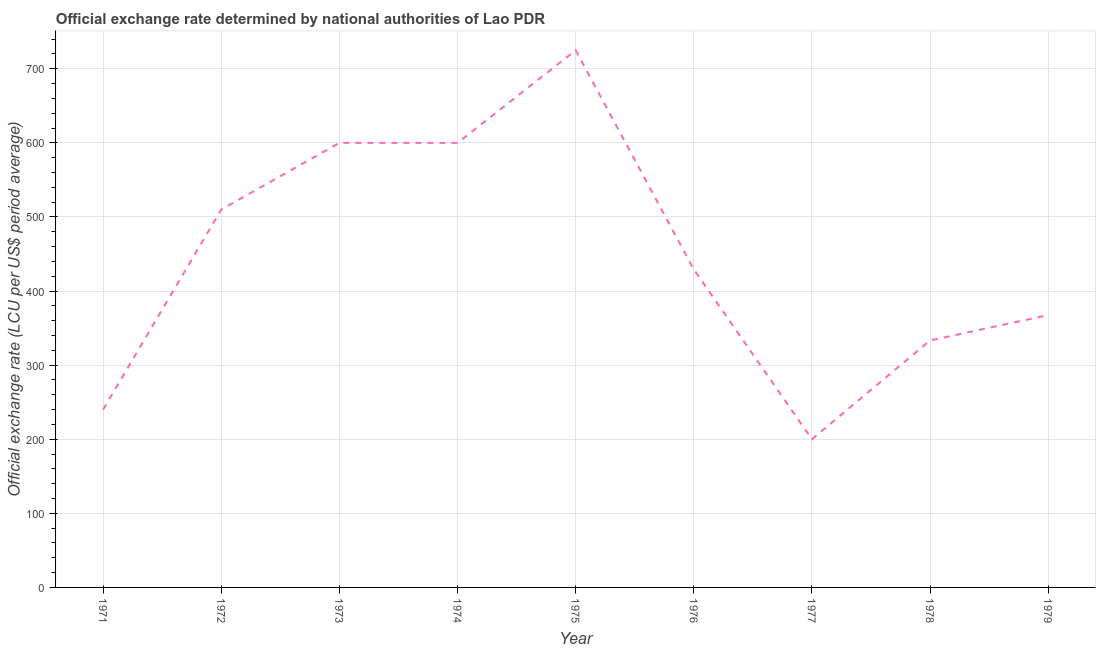What is the official exchange rate in 1978?
Offer a very short reply. 333.33. Across all years, what is the maximum official exchange rate?
Make the answer very short. 725. Across all years, what is the minimum official exchange rate?
Keep it short and to the point. 200. In which year was the official exchange rate maximum?
Offer a terse response. 1975. In which year was the official exchange rate minimum?
Your response must be concise. 1977. What is the sum of the official exchange rate?
Keep it short and to the point. 4005. What is the difference between the official exchange rate in 1975 and 1978?
Your answer should be very brief. 391.67. What is the average official exchange rate per year?
Ensure brevity in your answer.  445. What is the median official exchange rate?
Keep it short and to the point. 429.17. In how many years, is the official exchange rate greater than 360 ?
Your response must be concise. 6. Do a majority of the years between 1978 and 1976 (inclusive) have official exchange rate greater than 480 ?
Your answer should be very brief. No. What is the ratio of the official exchange rate in 1973 to that in 1976?
Offer a terse response. 1.4. What is the difference between the highest and the second highest official exchange rate?
Provide a short and direct response. 125. What is the difference between the highest and the lowest official exchange rate?
Your answer should be very brief. 525. How many lines are there?
Provide a succinct answer. 1. What is the difference between two consecutive major ticks on the Y-axis?
Your answer should be compact. 100. What is the title of the graph?
Make the answer very short. Official exchange rate determined by national authorities of Lao PDR. What is the label or title of the X-axis?
Your answer should be compact. Year. What is the label or title of the Y-axis?
Offer a very short reply. Official exchange rate (LCU per US$ period average). What is the Official exchange rate (LCU per US$ period average) of 1971?
Your answer should be very brief. 240. What is the Official exchange rate (LCU per US$ period average) of 1972?
Your answer should be compact. 510. What is the Official exchange rate (LCU per US$ period average) of 1973?
Offer a very short reply. 600. What is the Official exchange rate (LCU per US$ period average) of 1974?
Offer a terse response. 600. What is the Official exchange rate (LCU per US$ period average) of 1975?
Offer a very short reply. 725. What is the Official exchange rate (LCU per US$ period average) of 1976?
Keep it short and to the point. 429.17. What is the Official exchange rate (LCU per US$ period average) in 1977?
Your answer should be very brief. 200. What is the Official exchange rate (LCU per US$ period average) of 1978?
Your answer should be very brief. 333.33. What is the Official exchange rate (LCU per US$ period average) in 1979?
Provide a short and direct response. 367.5. What is the difference between the Official exchange rate (LCU per US$ period average) in 1971 and 1972?
Your answer should be very brief. -270. What is the difference between the Official exchange rate (LCU per US$ period average) in 1971 and 1973?
Offer a very short reply. -360. What is the difference between the Official exchange rate (LCU per US$ period average) in 1971 and 1974?
Your answer should be compact. -360. What is the difference between the Official exchange rate (LCU per US$ period average) in 1971 and 1975?
Keep it short and to the point. -485. What is the difference between the Official exchange rate (LCU per US$ period average) in 1971 and 1976?
Offer a very short reply. -189.17. What is the difference between the Official exchange rate (LCU per US$ period average) in 1971 and 1977?
Your answer should be very brief. 40. What is the difference between the Official exchange rate (LCU per US$ period average) in 1971 and 1978?
Provide a short and direct response. -93.33. What is the difference between the Official exchange rate (LCU per US$ period average) in 1971 and 1979?
Give a very brief answer. -127.5. What is the difference between the Official exchange rate (LCU per US$ period average) in 1972 and 1973?
Your response must be concise. -90. What is the difference between the Official exchange rate (LCU per US$ period average) in 1972 and 1974?
Your answer should be very brief. -90. What is the difference between the Official exchange rate (LCU per US$ period average) in 1972 and 1975?
Your response must be concise. -215. What is the difference between the Official exchange rate (LCU per US$ period average) in 1972 and 1976?
Give a very brief answer. 80.83. What is the difference between the Official exchange rate (LCU per US$ period average) in 1972 and 1977?
Your response must be concise. 310. What is the difference between the Official exchange rate (LCU per US$ period average) in 1972 and 1978?
Give a very brief answer. 176.67. What is the difference between the Official exchange rate (LCU per US$ period average) in 1972 and 1979?
Offer a terse response. 142.5. What is the difference between the Official exchange rate (LCU per US$ period average) in 1973 and 1974?
Give a very brief answer. 0. What is the difference between the Official exchange rate (LCU per US$ period average) in 1973 and 1975?
Provide a short and direct response. -125. What is the difference between the Official exchange rate (LCU per US$ period average) in 1973 and 1976?
Make the answer very short. 170.83. What is the difference between the Official exchange rate (LCU per US$ period average) in 1973 and 1977?
Your answer should be compact. 400. What is the difference between the Official exchange rate (LCU per US$ period average) in 1973 and 1978?
Your answer should be very brief. 266.67. What is the difference between the Official exchange rate (LCU per US$ period average) in 1973 and 1979?
Make the answer very short. 232.5. What is the difference between the Official exchange rate (LCU per US$ period average) in 1974 and 1975?
Give a very brief answer. -125. What is the difference between the Official exchange rate (LCU per US$ period average) in 1974 and 1976?
Your response must be concise. 170.83. What is the difference between the Official exchange rate (LCU per US$ period average) in 1974 and 1977?
Make the answer very short. 400. What is the difference between the Official exchange rate (LCU per US$ period average) in 1974 and 1978?
Make the answer very short. 266.67. What is the difference between the Official exchange rate (LCU per US$ period average) in 1974 and 1979?
Keep it short and to the point. 232.5. What is the difference between the Official exchange rate (LCU per US$ period average) in 1975 and 1976?
Your answer should be very brief. 295.83. What is the difference between the Official exchange rate (LCU per US$ period average) in 1975 and 1977?
Provide a short and direct response. 525. What is the difference between the Official exchange rate (LCU per US$ period average) in 1975 and 1978?
Your answer should be very brief. 391.67. What is the difference between the Official exchange rate (LCU per US$ period average) in 1975 and 1979?
Give a very brief answer. 357.5. What is the difference between the Official exchange rate (LCU per US$ period average) in 1976 and 1977?
Make the answer very short. 229.17. What is the difference between the Official exchange rate (LCU per US$ period average) in 1976 and 1978?
Ensure brevity in your answer.  95.83. What is the difference between the Official exchange rate (LCU per US$ period average) in 1976 and 1979?
Provide a succinct answer. 61.67. What is the difference between the Official exchange rate (LCU per US$ period average) in 1977 and 1978?
Offer a terse response. -133.33. What is the difference between the Official exchange rate (LCU per US$ period average) in 1977 and 1979?
Ensure brevity in your answer.  -167.5. What is the difference between the Official exchange rate (LCU per US$ period average) in 1978 and 1979?
Keep it short and to the point. -34.17. What is the ratio of the Official exchange rate (LCU per US$ period average) in 1971 to that in 1972?
Keep it short and to the point. 0.47. What is the ratio of the Official exchange rate (LCU per US$ period average) in 1971 to that in 1973?
Ensure brevity in your answer.  0.4. What is the ratio of the Official exchange rate (LCU per US$ period average) in 1971 to that in 1975?
Offer a terse response. 0.33. What is the ratio of the Official exchange rate (LCU per US$ period average) in 1971 to that in 1976?
Provide a succinct answer. 0.56. What is the ratio of the Official exchange rate (LCU per US$ period average) in 1971 to that in 1978?
Give a very brief answer. 0.72. What is the ratio of the Official exchange rate (LCU per US$ period average) in 1971 to that in 1979?
Your answer should be very brief. 0.65. What is the ratio of the Official exchange rate (LCU per US$ period average) in 1972 to that in 1975?
Your answer should be compact. 0.7. What is the ratio of the Official exchange rate (LCU per US$ period average) in 1972 to that in 1976?
Offer a terse response. 1.19. What is the ratio of the Official exchange rate (LCU per US$ period average) in 1972 to that in 1977?
Offer a terse response. 2.55. What is the ratio of the Official exchange rate (LCU per US$ period average) in 1972 to that in 1978?
Offer a terse response. 1.53. What is the ratio of the Official exchange rate (LCU per US$ period average) in 1972 to that in 1979?
Keep it short and to the point. 1.39. What is the ratio of the Official exchange rate (LCU per US$ period average) in 1973 to that in 1975?
Make the answer very short. 0.83. What is the ratio of the Official exchange rate (LCU per US$ period average) in 1973 to that in 1976?
Offer a terse response. 1.4. What is the ratio of the Official exchange rate (LCU per US$ period average) in 1973 to that in 1977?
Your answer should be compact. 3. What is the ratio of the Official exchange rate (LCU per US$ period average) in 1973 to that in 1978?
Offer a terse response. 1.8. What is the ratio of the Official exchange rate (LCU per US$ period average) in 1973 to that in 1979?
Ensure brevity in your answer.  1.63. What is the ratio of the Official exchange rate (LCU per US$ period average) in 1974 to that in 1975?
Your answer should be very brief. 0.83. What is the ratio of the Official exchange rate (LCU per US$ period average) in 1974 to that in 1976?
Make the answer very short. 1.4. What is the ratio of the Official exchange rate (LCU per US$ period average) in 1974 to that in 1979?
Your answer should be very brief. 1.63. What is the ratio of the Official exchange rate (LCU per US$ period average) in 1975 to that in 1976?
Give a very brief answer. 1.69. What is the ratio of the Official exchange rate (LCU per US$ period average) in 1975 to that in 1977?
Keep it short and to the point. 3.62. What is the ratio of the Official exchange rate (LCU per US$ period average) in 1975 to that in 1978?
Make the answer very short. 2.17. What is the ratio of the Official exchange rate (LCU per US$ period average) in 1975 to that in 1979?
Provide a short and direct response. 1.97. What is the ratio of the Official exchange rate (LCU per US$ period average) in 1976 to that in 1977?
Provide a short and direct response. 2.15. What is the ratio of the Official exchange rate (LCU per US$ period average) in 1976 to that in 1978?
Ensure brevity in your answer.  1.29. What is the ratio of the Official exchange rate (LCU per US$ period average) in 1976 to that in 1979?
Keep it short and to the point. 1.17. What is the ratio of the Official exchange rate (LCU per US$ period average) in 1977 to that in 1978?
Offer a very short reply. 0.6. What is the ratio of the Official exchange rate (LCU per US$ period average) in 1977 to that in 1979?
Offer a terse response. 0.54. What is the ratio of the Official exchange rate (LCU per US$ period average) in 1978 to that in 1979?
Offer a terse response. 0.91. 